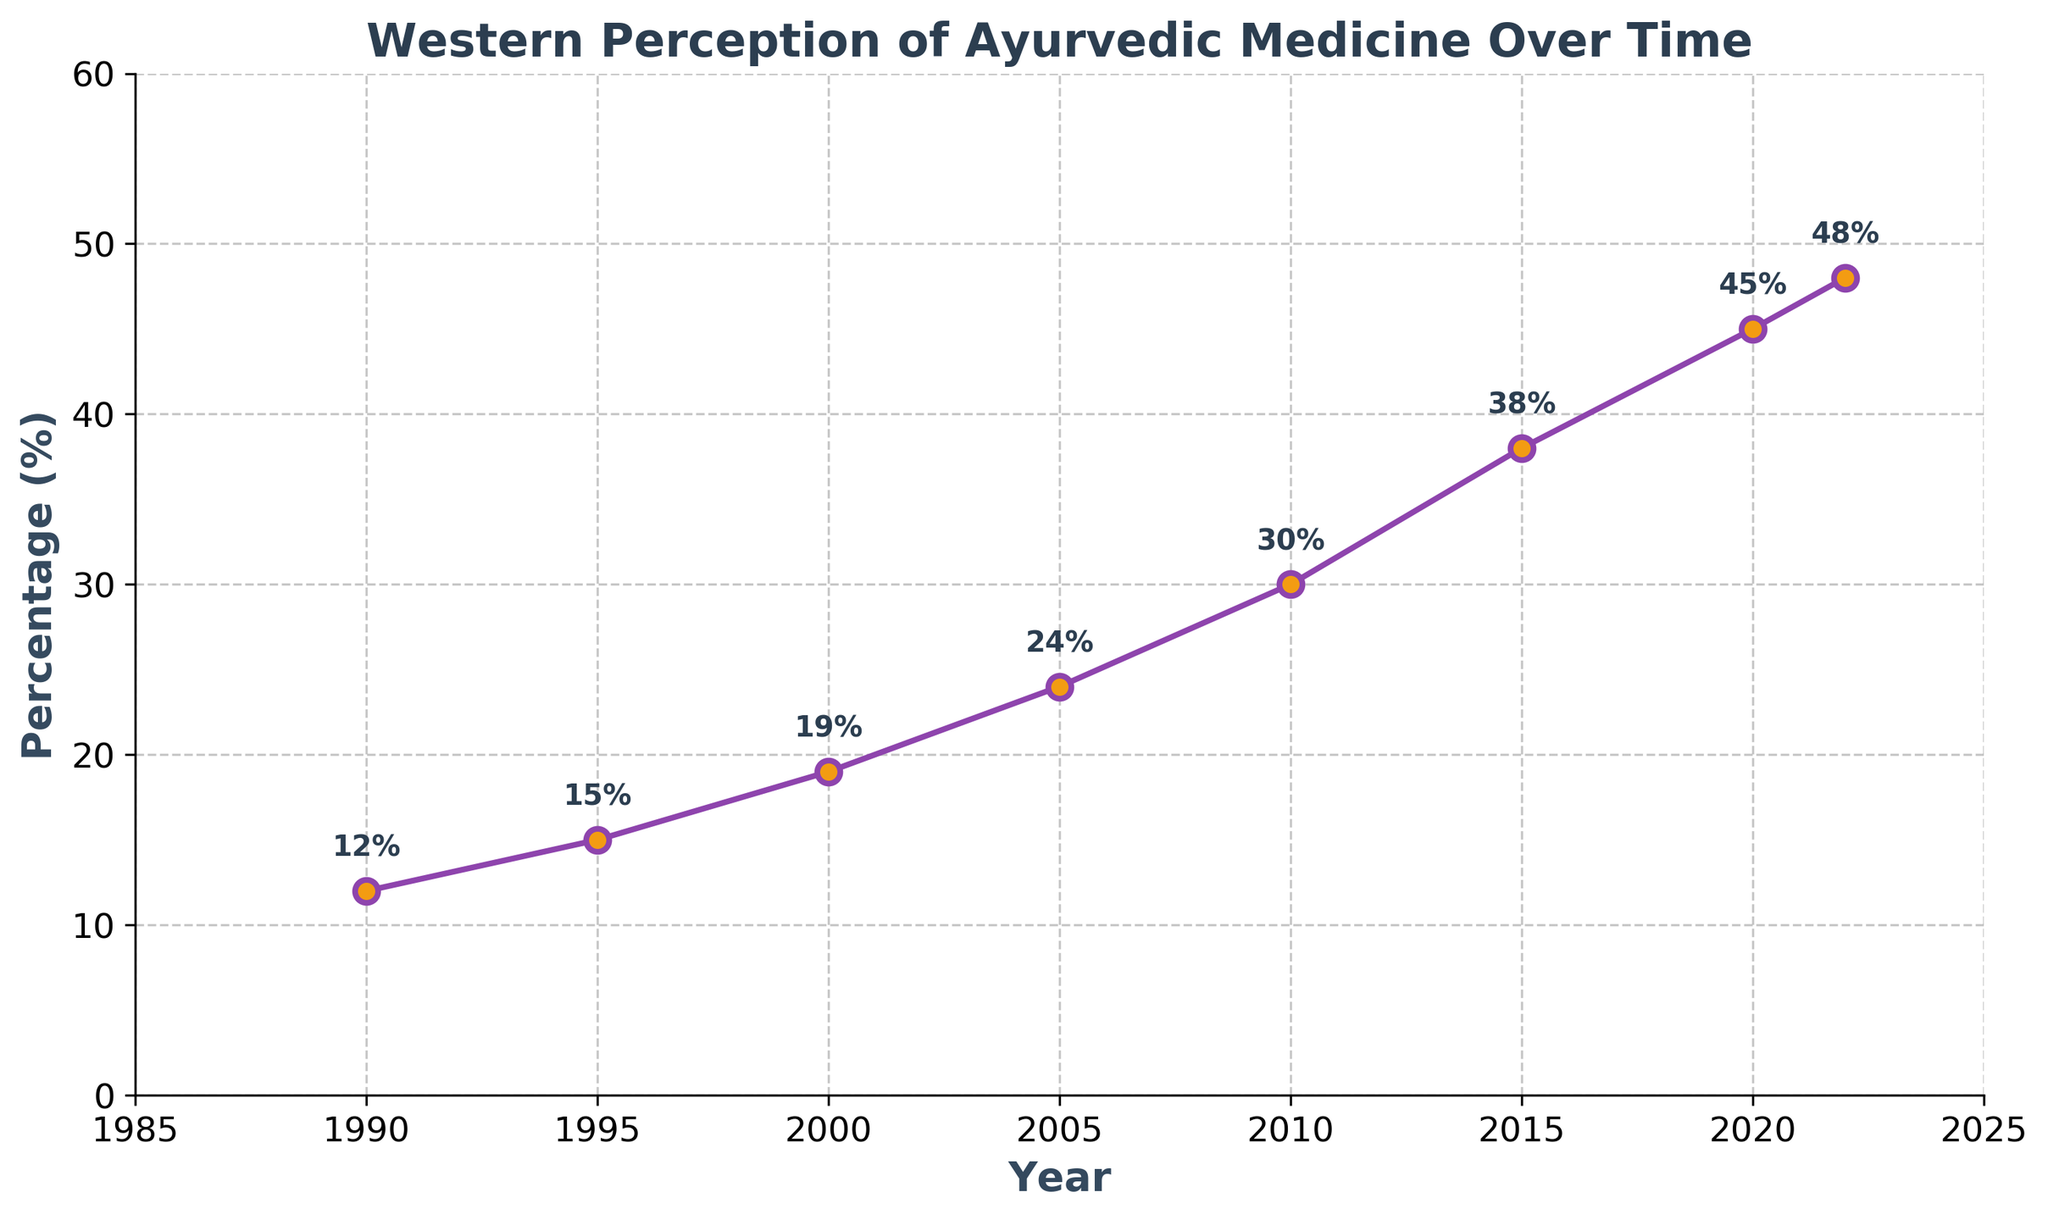What is the percentage increase in the positive perception of Ayurvedic medicine from 1990 to 2020? To find the percentage increase from 1990 to 2020, subtract the percentage value in 1990 (12%) from the percentage value in 2020 (45%). The difference is 45% - 12% = 33%.
Answer: 33% How many times higher was the positive perception of Ayurvedic medicine in 2020 compared to 1990? To determine how many times higher, divide the percentage in 2020 (45%) by the percentage in 1990 (12%). 45% / 12% = 3.75.
Answer: 3.75 During which decade did the perception of Ayurvedic medicine increase the most? By calculating the increases for each decade: 
1990 to 2000: 19% - 12% = 7% 
2000 to 2010: 30% - 19% = 11% 
2010 to 2020: 45% - 30% = 15% 
The largest increase occurred from 2010 to 2020.
Answer: 2010-2020 Which year had the greatest single-year jump in positive perception? Look for the greatest increase between consecutive data points:
1990 to 1995: 15% - 12% = 3%
1995 to 2000: 19% - 15% = 4%
2000 to 2005: 24% - 19% = 5%
2005 to 2010: 30% - 24% = 6%
2010 to 2015: 38% - 30% = 8%
2015 to 2020: 45% - 38% = 7%
2020 to 2022: 48% - 45% = 3%
The greatest single-year jump was from 2010 to 2015 with an 8% increase.
Answer: 2010-2015 What is the average percentage of Westerners viewing Ayurvedic medicine positively across all surveyed years? Sum all the percentages (12+15+19+24+30+38+45+48) and divide by the number of years (8). 
Sum = 231, Average = 231 / 8 = 28.875%.
Answer: 28.875% How does the percentage change from 1995 to 2005 compare to the change from 2005 to 2015? First, calculate the changes:
1995 to 2005: 24% - 15% = 9%
2005 to 2015: 38% - 24% = 14%
The change from 2005 to 2015 is 14%, which is greater than the change from 1995 to 2005, which is 9%.
Answer: 14% vs 9% What is the trend in the positive perception of Ayurvedic medicine from 1990 to 2022 based on the curve's shape? The curve shows an upward trend, becoming steeper after 2000, indicating a consistent increase in positive perception over time.
Answer: Upward trend Which year marked half of the final year's positive perception? Half of the 2022 value (48%) is 24%. The year when the percentage was closest to 24% was 2005.
Answer: 2005 Compare the rate of increase in positive perception between the periods 1990-2000 and 2010-2020. Rate of increase:
1990 to 2000: (19% - 12%) / 10 = 0.7% per year
2010 to 2020: (45% - 30%) / 10 = 1.5% per year
The rate of increase between 2010-2020 (1.5% per year) is greater than between 1990-2000 (0.7% per year).
Answer: 1.5% per year vs 0.7% per year 